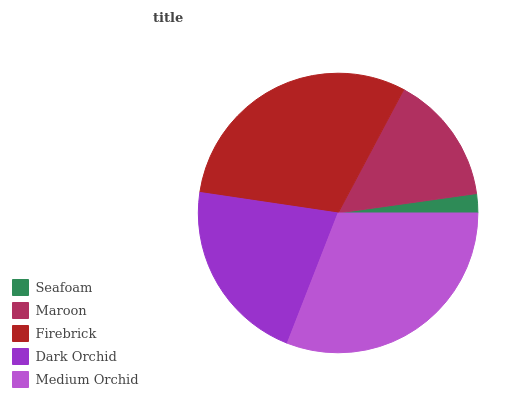Is Seafoam the minimum?
Answer yes or no. Yes. Is Medium Orchid the maximum?
Answer yes or no. Yes. Is Maroon the minimum?
Answer yes or no. No. Is Maroon the maximum?
Answer yes or no. No. Is Maroon greater than Seafoam?
Answer yes or no. Yes. Is Seafoam less than Maroon?
Answer yes or no. Yes. Is Seafoam greater than Maroon?
Answer yes or no. No. Is Maroon less than Seafoam?
Answer yes or no. No. Is Dark Orchid the high median?
Answer yes or no. Yes. Is Dark Orchid the low median?
Answer yes or no. Yes. Is Maroon the high median?
Answer yes or no. No. Is Seafoam the low median?
Answer yes or no. No. 